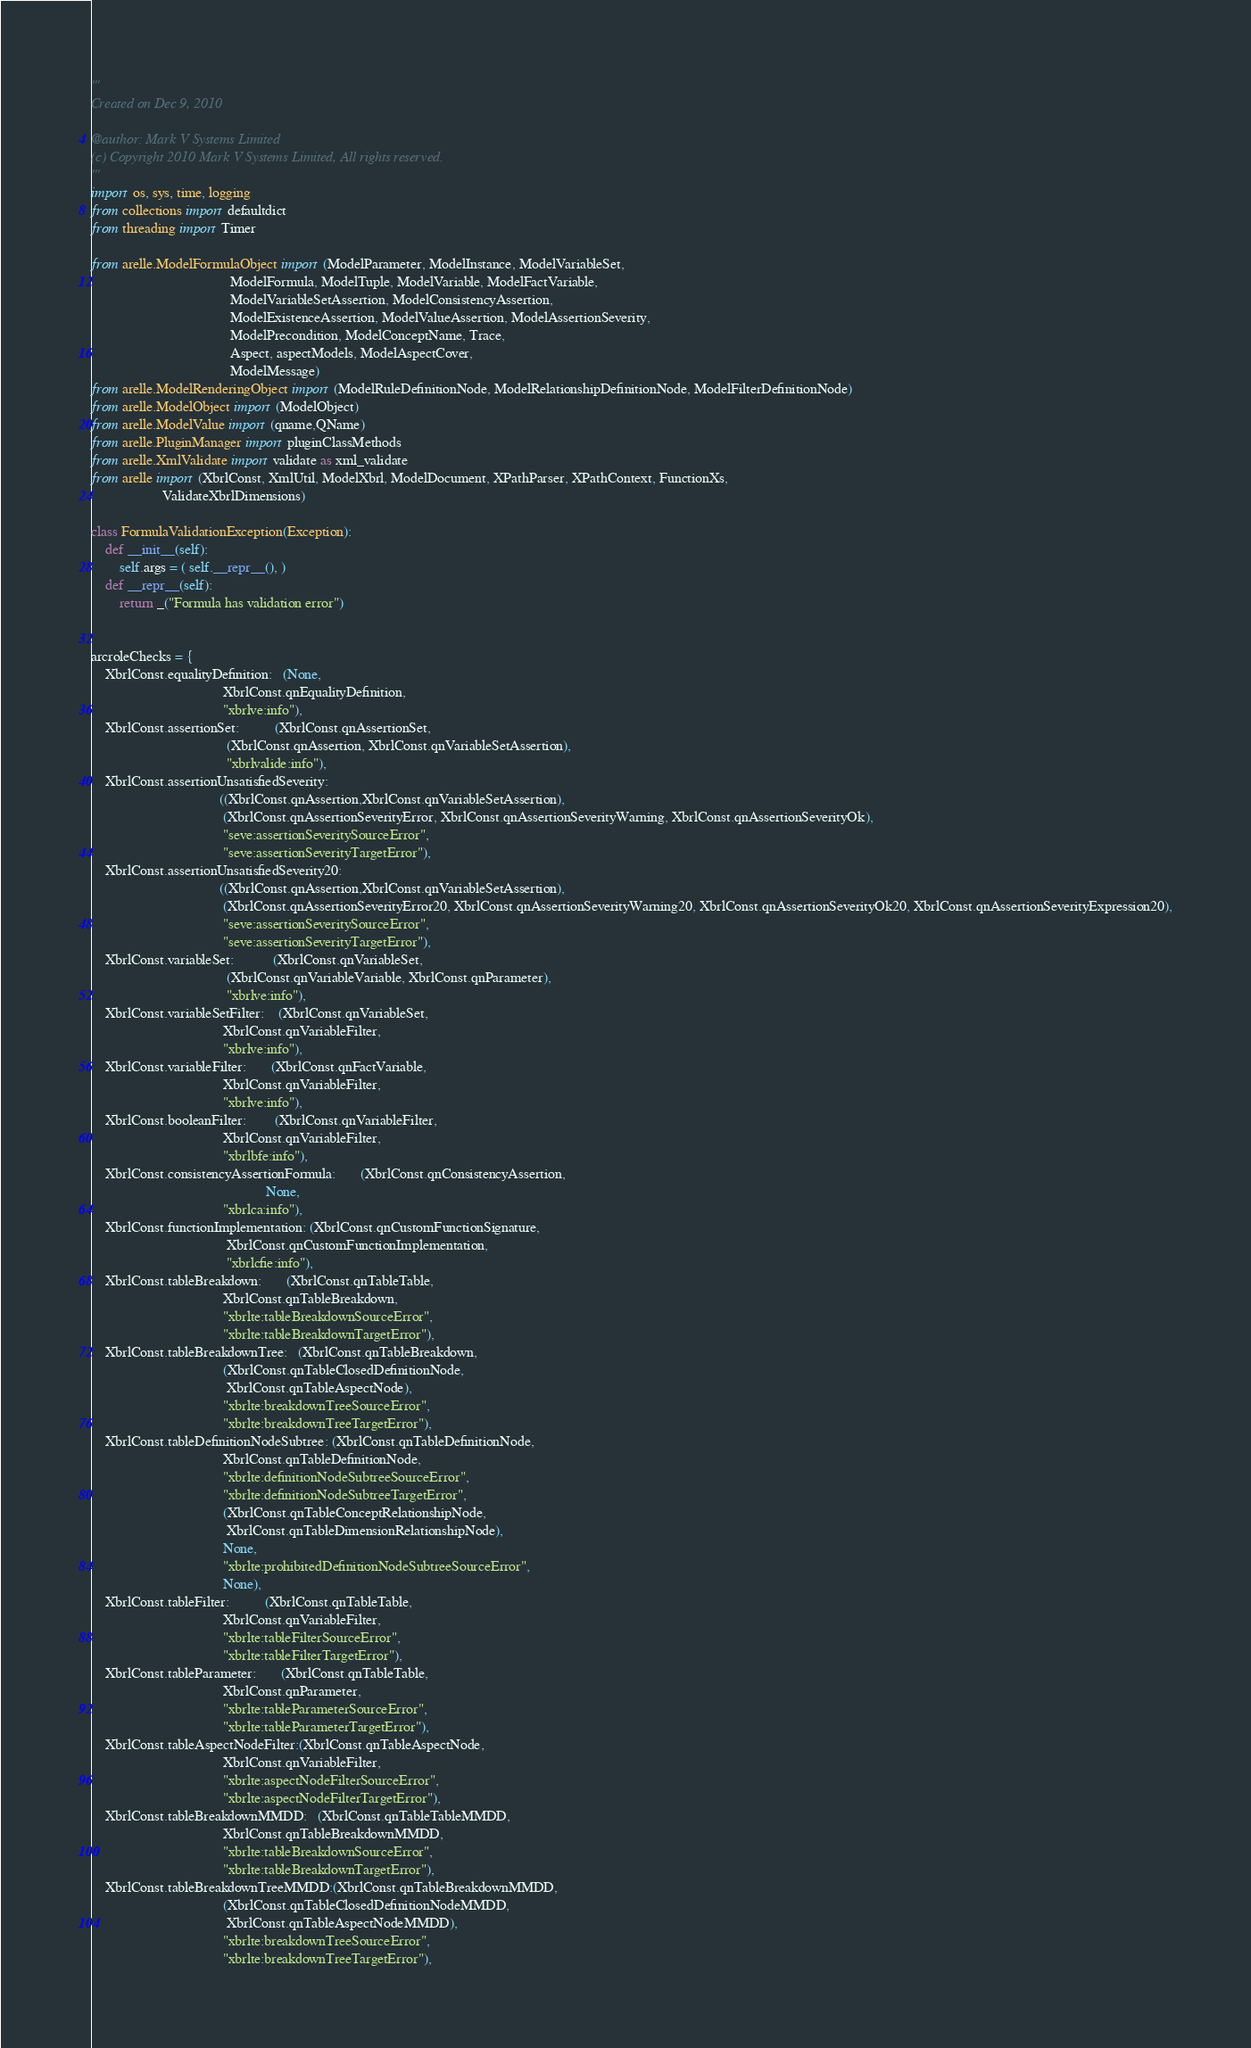Convert code to text. <code><loc_0><loc_0><loc_500><loc_500><_Python_>'''
Created on Dec 9, 2010

@author: Mark V Systems Limited
(c) Copyright 2010 Mark V Systems Limited, All rights reserved.
'''
import os, sys, time, logging
from collections import defaultdict
from threading import Timer

from arelle.ModelFormulaObject import (ModelParameter, ModelInstance, ModelVariableSet,
                                       ModelFormula, ModelTuple, ModelVariable, ModelFactVariable, 
                                       ModelVariableSetAssertion, ModelConsistencyAssertion,
                                       ModelExistenceAssertion, ModelValueAssertion, ModelAssertionSeverity,
                                       ModelPrecondition, ModelConceptName, Trace,
                                       Aspect, aspectModels, ModelAspectCover,
                                       ModelMessage)
from arelle.ModelRenderingObject import (ModelRuleDefinitionNode, ModelRelationshipDefinitionNode, ModelFilterDefinitionNode)
from arelle.ModelObject import (ModelObject)
from arelle.ModelValue import (qname,QName)
from arelle.PluginManager import pluginClassMethods
from arelle.XmlValidate import validate as xml_validate
from arelle import (XbrlConst, XmlUtil, ModelXbrl, ModelDocument, XPathParser, XPathContext, FunctionXs,
                    ValidateXbrlDimensions) 

class FormulaValidationException(Exception):
    def __init__(self):
        self.args = ( self.__repr__(), )
    def __repr__(self):
        return _("Formula has validation error")


arcroleChecks = {
    XbrlConst.equalityDefinition:   (None, 
                                     XbrlConst.qnEqualityDefinition, 
                                     "xbrlve:info"),
    XbrlConst.assertionSet:          (XbrlConst.qnAssertionSet,
                                      (XbrlConst.qnAssertion, XbrlConst.qnVariableSetAssertion),
                                      "xbrlvalide:info"),
    XbrlConst.assertionUnsatisfiedSeverity:
                                    ((XbrlConst.qnAssertion,XbrlConst.qnVariableSetAssertion),
                                     (XbrlConst.qnAssertionSeverityError, XbrlConst.qnAssertionSeverityWarning, XbrlConst.qnAssertionSeverityOk),
                                     "seve:assertionSeveritySourceError",
                                     "seve:assertionSeverityTargetError"),
    XbrlConst.assertionUnsatisfiedSeverity20:
                                    ((XbrlConst.qnAssertion,XbrlConst.qnVariableSetAssertion),
                                     (XbrlConst.qnAssertionSeverityError20, XbrlConst.qnAssertionSeverityWarning20, XbrlConst.qnAssertionSeverityOk20, XbrlConst.qnAssertionSeverityExpression20),
                                     "seve:assertionSeveritySourceError",
                                     "seve:assertionSeverityTargetError"),
    XbrlConst.variableSet:           (XbrlConst.qnVariableSet,
                                      (XbrlConst.qnVariableVariable, XbrlConst.qnParameter),
                                      "xbrlve:info"),
    XbrlConst.variableSetFilter:    (XbrlConst.qnVariableSet, 
                                     XbrlConst.qnVariableFilter, 
                                     "xbrlve:info"),
    XbrlConst.variableFilter:       (XbrlConst.qnFactVariable, 
                                     XbrlConst.qnVariableFilter, 
                                     "xbrlve:info"),
    XbrlConst.booleanFilter:        (XbrlConst.qnVariableFilter, 
                                     XbrlConst.qnVariableFilter, 
                                     "xbrlbfe:info"),
    XbrlConst.consistencyAssertionFormula:       (XbrlConst.qnConsistencyAssertion, 
                                                 None, 
                                     "xbrlca:info"),
    XbrlConst.functionImplementation: (XbrlConst.qnCustomFunctionSignature,
                                      XbrlConst.qnCustomFunctionImplementation,
                                      "xbrlcfie:info"),
    XbrlConst.tableBreakdown:       (XbrlConst.qnTableTable,
                                     XbrlConst.qnTableBreakdown,
                                     "xbrlte:tableBreakdownSourceError",
                                     "xbrlte:tableBreakdownTargetError"),
    XbrlConst.tableBreakdownTree:   (XbrlConst.qnTableBreakdown,
                                     (XbrlConst.qnTableClosedDefinitionNode,
                                      XbrlConst.qnTableAspectNode),
                                     "xbrlte:breakdownTreeSourceError",
                                     "xbrlte:breakdownTreeTargetError"),
    XbrlConst.tableDefinitionNodeSubtree: (XbrlConst.qnTableDefinitionNode, 
                                     XbrlConst.qnTableDefinitionNode,
                                     "xbrlte:definitionNodeSubtreeSourceError",
                                     "xbrlte:definitionNodeSubtreeTargetError",
                                     (XbrlConst.qnTableConceptRelationshipNode,
                                      XbrlConst.qnTableDimensionRelationshipNode),
                                     None,
                                     "xbrlte:prohibitedDefinitionNodeSubtreeSourceError",
                                     None),
    XbrlConst.tableFilter:          (XbrlConst.qnTableTable, 
                                     XbrlConst.qnVariableFilter,
                                     "xbrlte:tableFilterSourceError",
                                     "xbrlte:tableFilterTargetError"),
    XbrlConst.tableParameter:       (XbrlConst.qnTableTable, 
                                     XbrlConst.qnParameter,
                                     "xbrlte:tableParameterSourceError",
                                     "xbrlte:tableParameterTargetError"),
    XbrlConst.tableAspectNodeFilter:(XbrlConst.qnTableAspectNode,
                                     XbrlConst.qnVariableFilter, 
                                     "xbrlte:aspectNodeFilterSourceError",
                                     "xbrlte:aspectNodeFilterTargetError"),
    XbrlConst.tableBreakdownMMDD:   (XbrlConst.qnTableTableMMDD,
                                     XbrlConst.qnTableBreakdownMMDD,
                                     "xbrlte:tableBreakdownSourceError",
                                     "xbrlte:tableBreakdownTargetError"),
    XbrlConst.tableBreakdownTreeMMDD:(XbrlConst.qnTableBreakdownMMDD,
                                     (XbrlConst.qnTableClosedDefinitionNodeMMDD,
                                      XbrlConst.qnTableAspectNodeMMDD),
                                     "xbrlte:breakdownTreeSourceError",
                                     "xbrlte:breakdownTreeTargetError"),</code> 